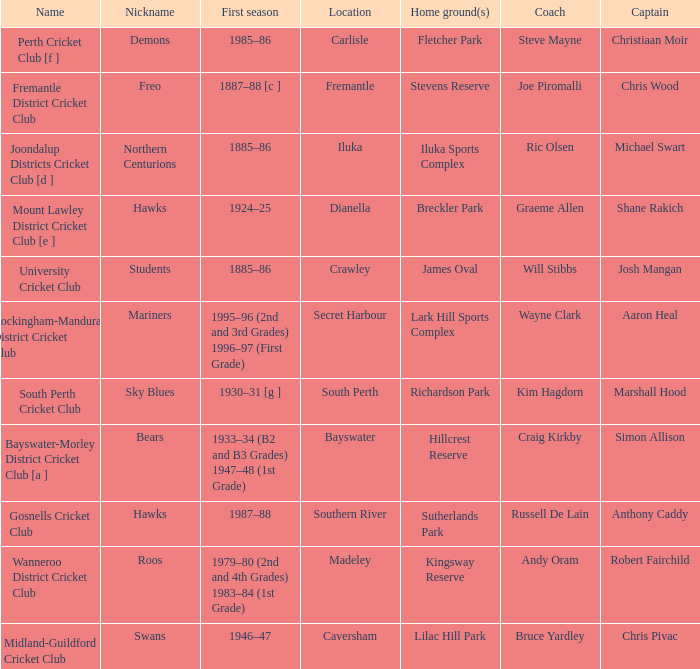What is the dates where Hillcrest Reserve is the home grounds? 1933–34 (B2 and B3 Grades) 1947–48 (1st Grade). 